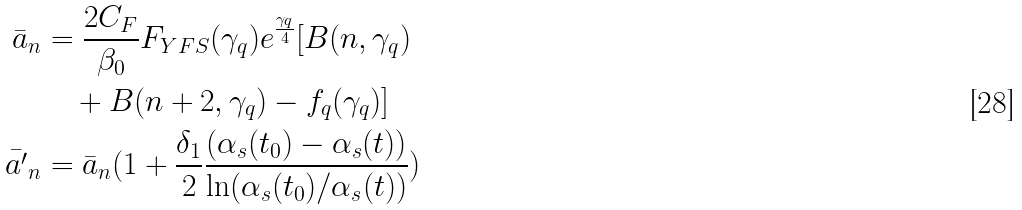<formula> <loc_0><loc_0><loc_500><loc_500>\bar { a } _ { n } & = \frac { 2 C _ { F } } { \beta _ { 0 } } F _ { Y F S } ( \gamma _ { q } ) e ^ { \frac { \gamma _ { q } } { 4 } } [ B ( n , \gamma _ { q } ) \\ & \quad + B ( n + 2 , \gamma _ { q } ) - f _ { q } ( \gamma _ { q } ) ] \\ \bar { a ^ { \prime } } _ { n } & = \bar { a } _ { n } ( 1 + \frac { \delta _ { 1 } } { 2 } \frac { ( \alpha _ { s } ( t _ { 0 } ) - \alpha _ { s } ( t ) ) } { \ln ( \alpha _ { s } ( t _ { 0 } ) / \alpha _ { s } ( t ) ) } )</formula> 